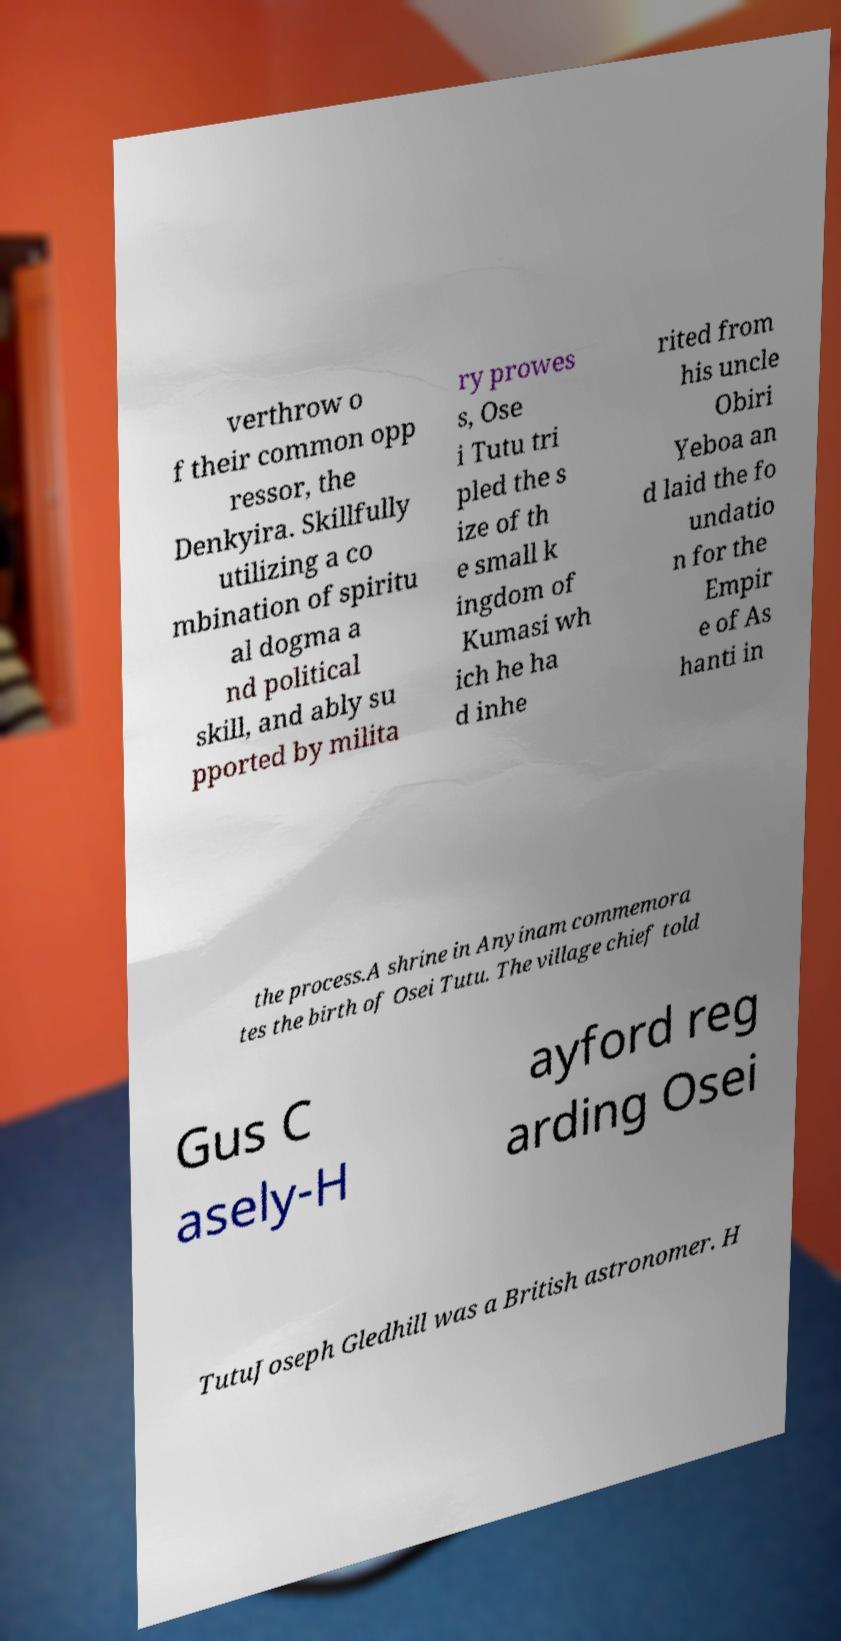Can you read and provide the text displayed in the image?This photo seems to have some interesting text. Can you extract and type it out for me? verthrow o f their common opp ressor, the Denkyira. Skillfully utilizing a co mbination of spiritu al dogma a nd political skill, and ably su pported by milita ry prowes s, Ose i Tutu tri pled the s ize of th e small k ingdom of Kumasi wh ich he ha d inhe rited from his uncle Obiri Yeboa an d laid the fo undatio n for the Empir e of As hanti in the process.A shrine in Anyinam commemora tes the birth of Osei Tutu. The village chief told Gus C asely-H ayford reg arding Osei TutuJoseph Gledhill was a British astronomer. H 